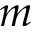Convert formula to latex. <formula><loc_0><loc_0><loc_500><loc_500>m</formula> 